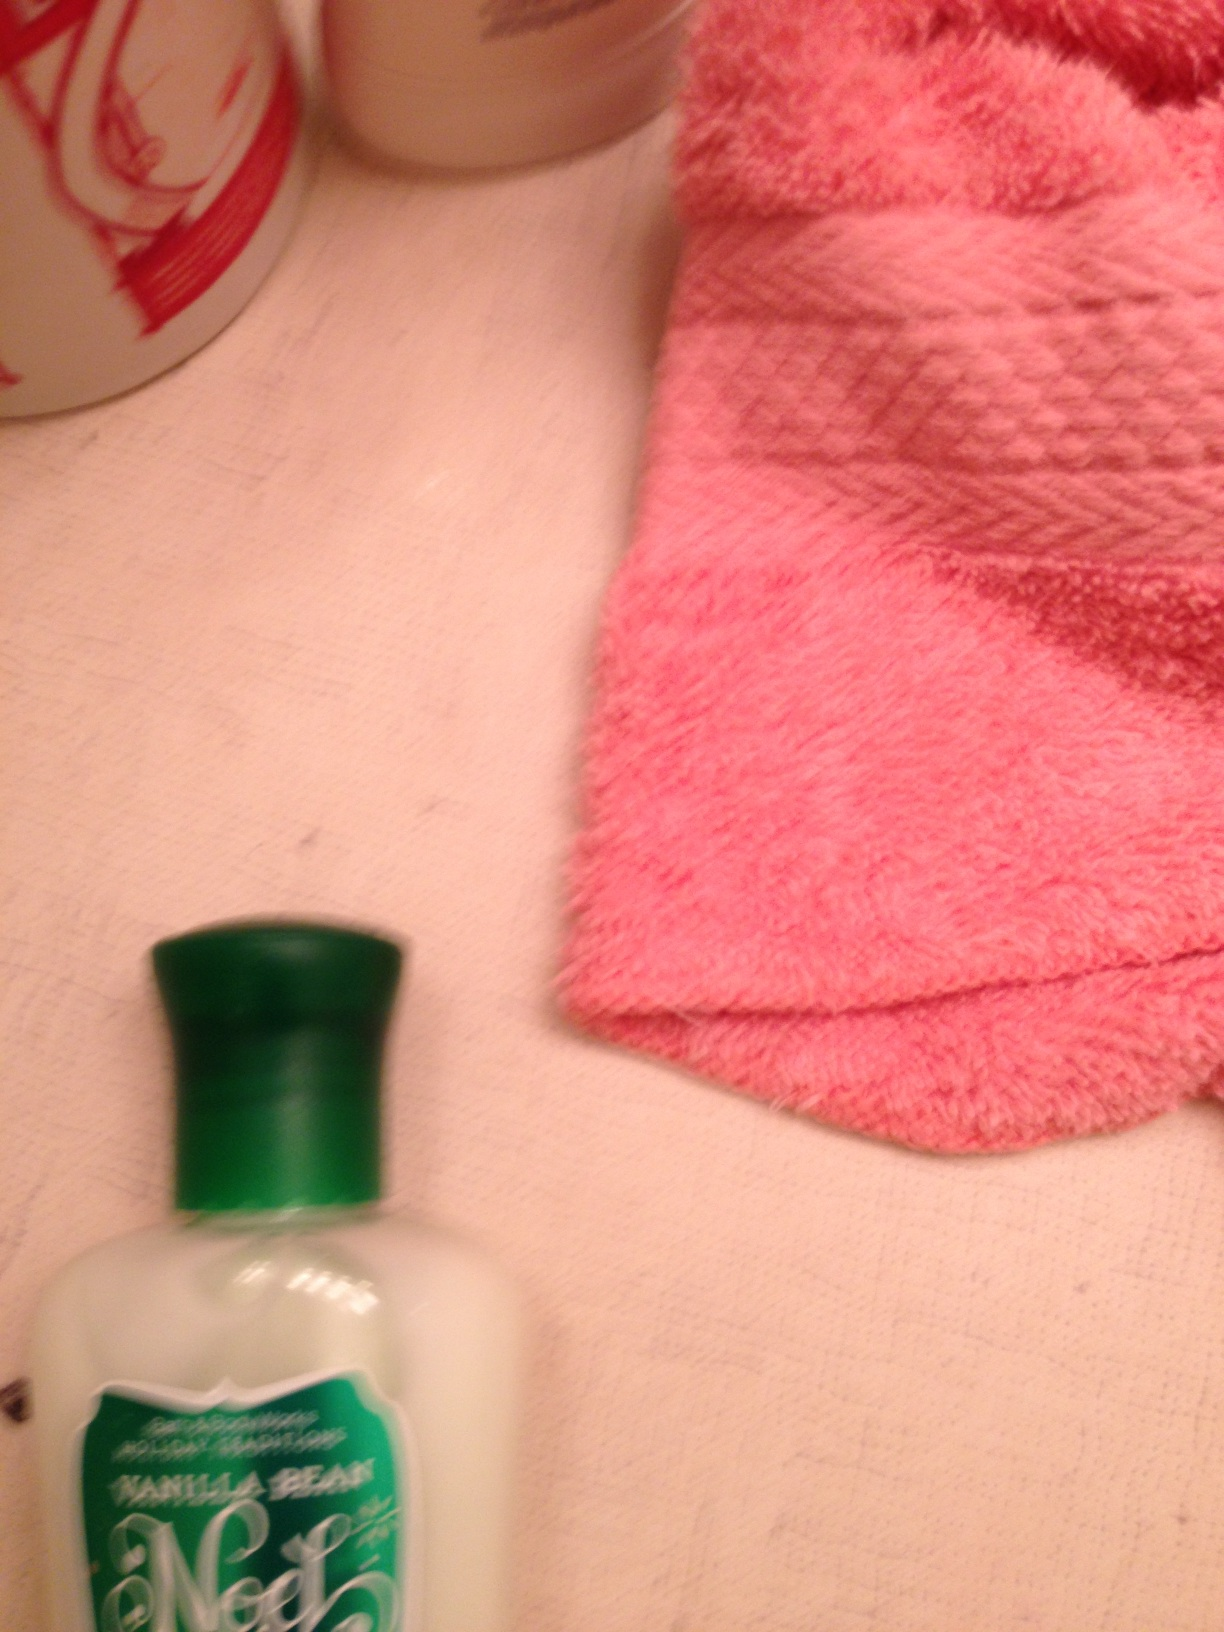What is this? This is a bottle of lotion. It appears to be labeled as 'Vanilla Bean Noel' and is likely a moisturizing body lotion. Such lotions are usually used to hydrate and soften the skin. 